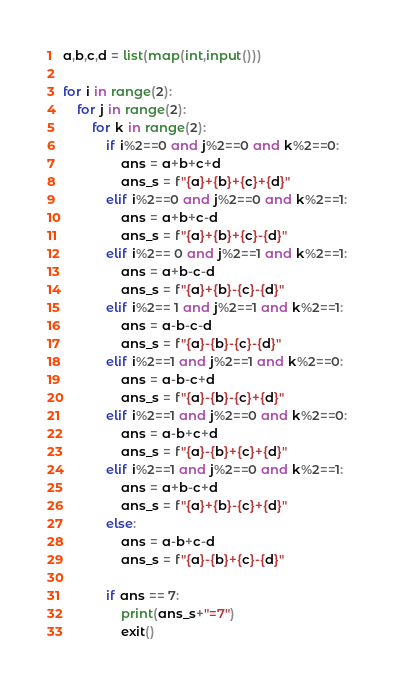Convert code to text. <code><loc_0><loc_0><loc_500><loc_500><_Python_>a,b,c,d = list(map(int,input()))

for i in range(2):
    for j in range(2):
        for k in range(2):
            if i%2==0 and j%2==0 and k%2==0:
                ans = a+b+c+d
                ans_s = f"{a}+{b}+{c}+{d}"
            elif i%2==0 and j%2==0 and k%2==1:
                ans = a+b+c-d
                ans_s = f"{a}+{b}+{c}-{d}"
            elif i%2== 0 and j%2==1 and k%2==1:
                ans = a+b-c-d
                ans_s = f"{a}+{b}-{c}-{d}"
            elif i%2== 1 and j%2==1 and k%2==1:
                ans = a-b-c-d
                ans_s = f"{a}-{b}-{c}-{d}"
            elif i%2==1 and j%2==1 and k%2==0:
                ans = a-b-c+d
                ans_s = f"{a}-{b}-{c}+{d}"
            elif i%2==1 and j%2==0 and k%2==0:
                ans = a-b+c+d
                ans_s = f"{a}-{b}+{c}+{d}"
            elif i%2==1 and j%2==0 and k%2==1:
                ans = a+b-c+d
                ans_s = f"{a}+{b}-{c}+{d}"
            else:
                ans = a-b+c-d
                ans_s = f"{a}-{b}+{c}-{d}"
            
            if ans == 7:
                print(ans_s+"=7")
                exit()
</code> 